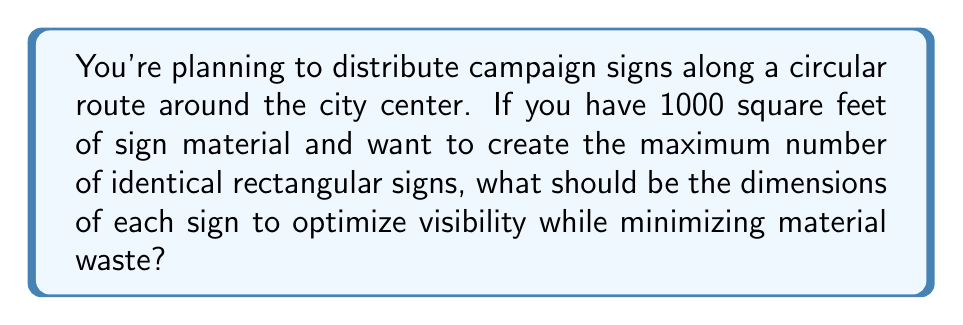Teach me how to tackle this problem. Let's approach this step-by-step:

1) Let the width of the sign be $w$ and the height be $h$.

2) The area of each sign is $A = w \times h$.

3) To maximize the number of signs, we need to minimize the area of each sign while maintaining visibility.

4) For optimal visibility, we want the sign to be as close to a square as possible while still being recognizably rectangular. A good ratio for this is the golden ratio, approximately 1.618.

5) Let's set up the equation:
   $\frac{w}{h} = 1.618$

6) We can rewrite this as: $w = 1.618h$

7) The area of the sign is then:
   $A = w \times h = 1.618h \times h = 1.618h^2$

8) We want to find $h$ that makes this area as close to a round number as possible for easy calculation and minimal waste. Let's try $h = 2$ feet:

   $A = 1.618 \times 2^2 = 1.618 \times 4 = 6.472$ sq ft

9) Rounding down to 6 sq ft per sign:
   $w = 1.618 \times 2 = 3.236$ feet, which we can round to 3.24 feet

10) With 1000 sq ft of material, we can make:
    $1000 \div 6 = 166.67$, or 166 signs with minimal waste

[asy]
size(200);
draw((0,0)--(3.24,0)--(3.24,2)--(0,2)--cycle);
label("3.24 ft", (1.62,0), S);
label("2 ft", (0,1), W);
[/asy]
Answer: $3.24$ ft $\times$ $2$ ft 